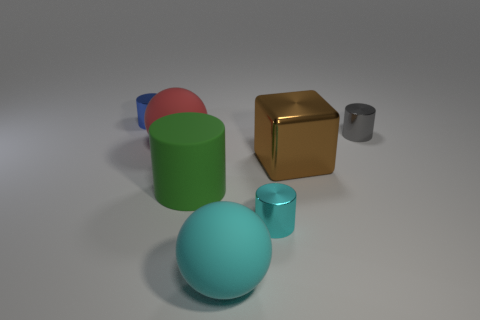Add 2 metal things. How many objects exist? 9 Subtract all blocks. How many objects are left? 6 Add 7 small gray shiny spheres. How many small gray shiny spheres exist? 7 Subtract 0 blue balls. How many objects are left? 7 Subtract all tiny gray objects. Subtract all red balls. How many objects are left? 5 Add 2 green matte objects. How many green matte objects are left? 3 